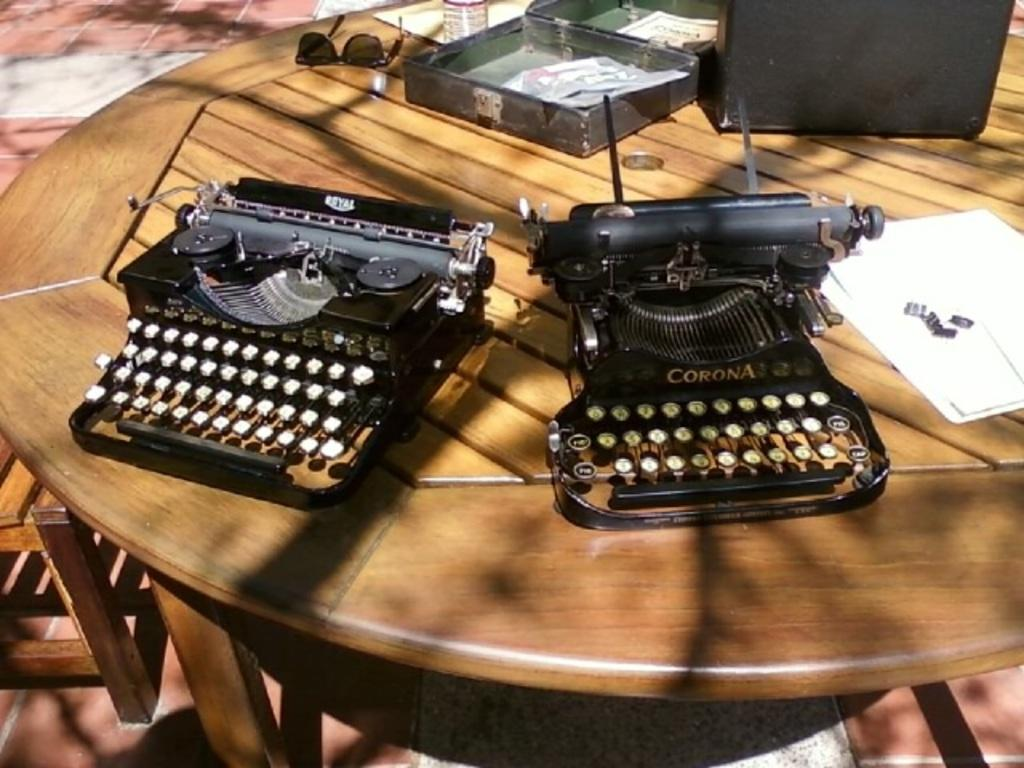<image>
Provide a brief description of the given image. Two corona black and gold typewriters that are placed on a table. 